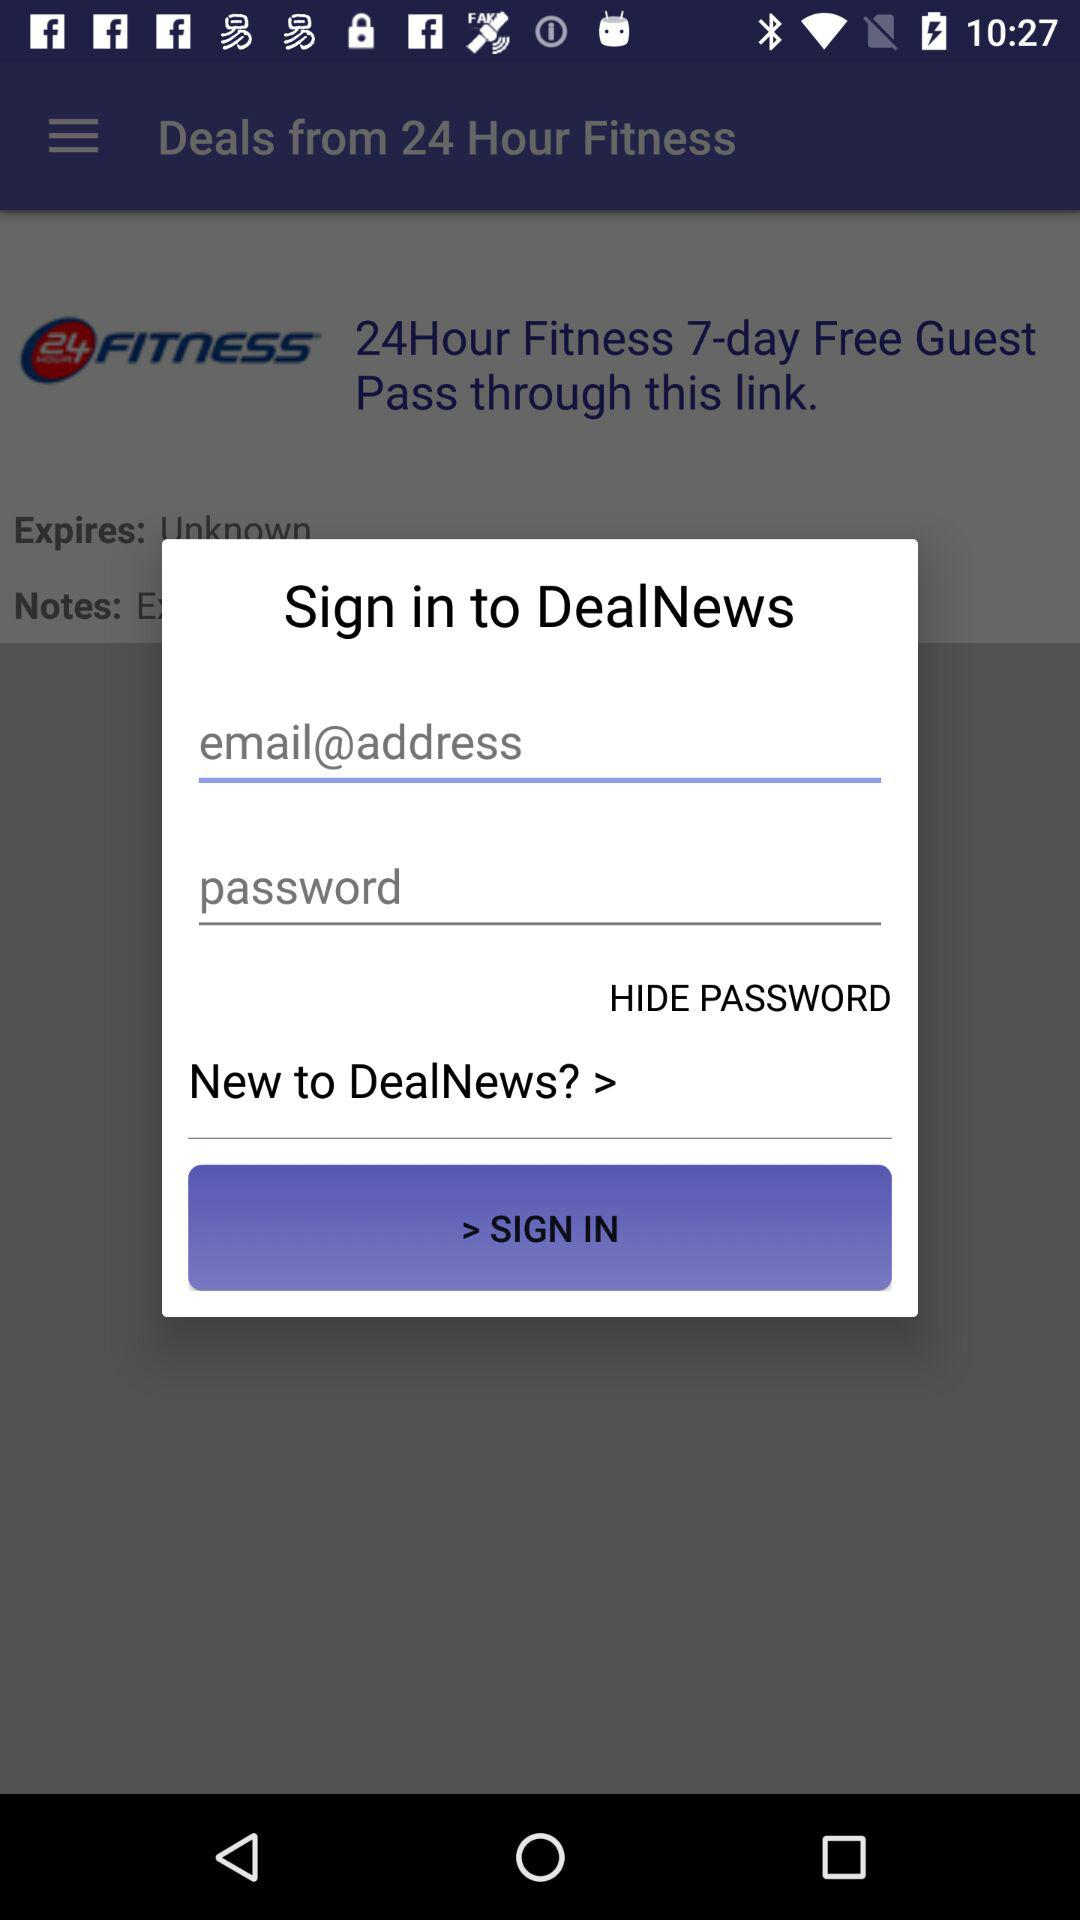What is the name of the application? The application name is "24 Hour Fitness". 